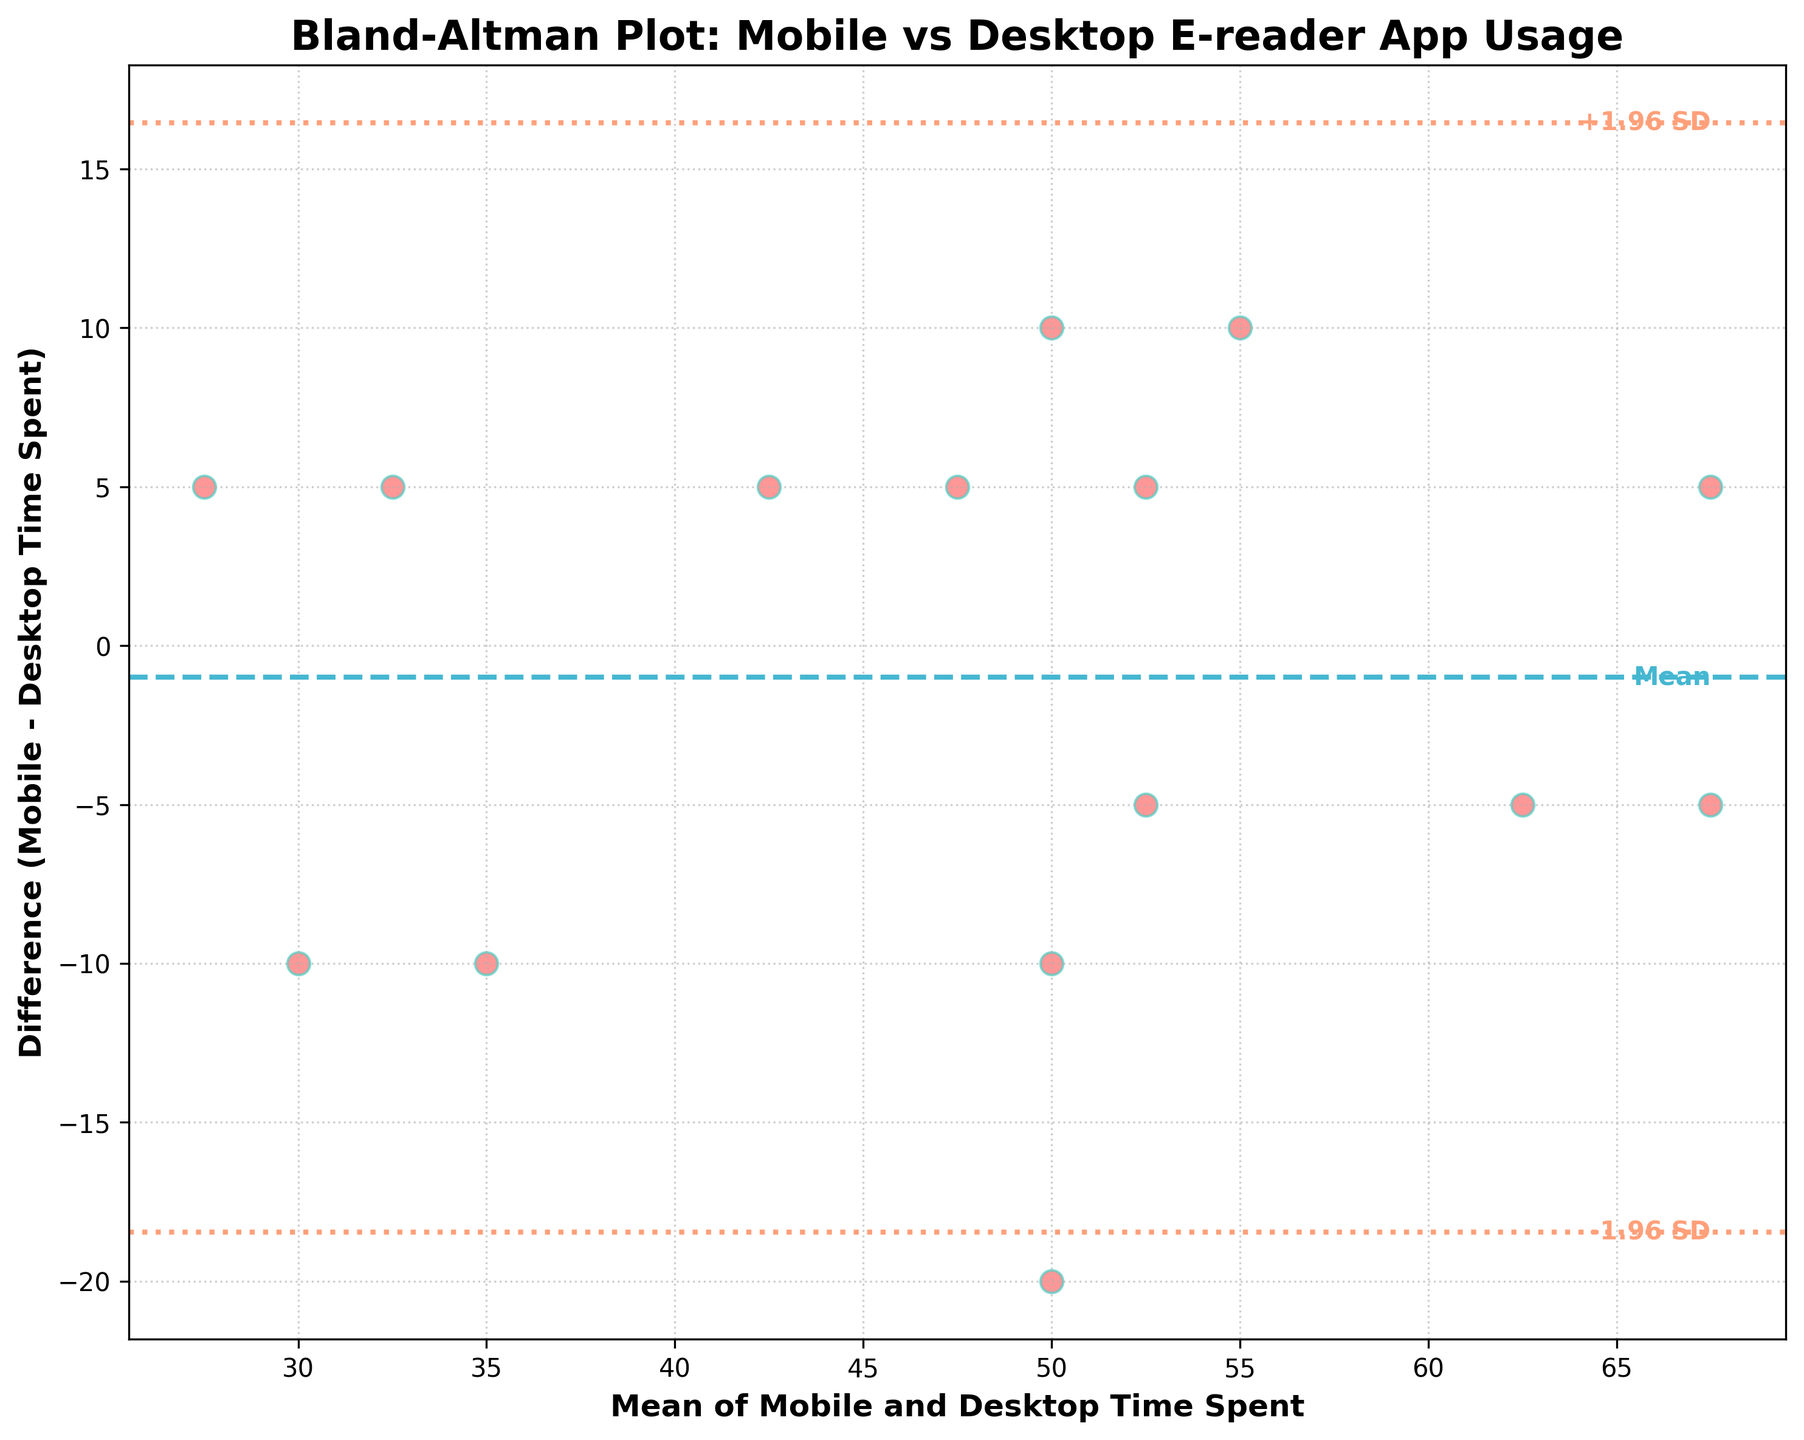What's the title of the plot? The title of the plot is typically located at the top of the figure. In this case, it reads "Bland-Altman Plot: Mobile vs Desktop E-reader App Usage".
Answer: Bland-Altman Plot: Mobile vs Desktop E-reader App Usage How many data points are there in this plot? The number of data points is equal to the number of users whose engagement metrics are plotted. By counting the red scatter points in the figure, we can determine the total.
Answer: 15 What do the horizontal dashed lines in the plot represent? The horizontal dashed lines represent the mean difference and the limits of agreement (LOA). The line in the middle is the mean difference, and the upper and lower lines denote the mean difference ± 1.96 times the standard deviation.
Answer: Mean difference and limits of agreement What is the mean difference between mobile and desktop time spent? The mean difference is indicated by the horizontal dashed line centrally located in the plot. There is also a text label next to this line.
Answer: 0 Based on the limits of agreement, what is the range within which most of the differences lie? The limits of agreement are defined as the mean difference ± 1.96 times the standard deviation. The plot includes labeled horizontal lines for these boundaries.
Answer: -17.36 to 17.36 Are there any points outside the limits of agreement? To find out if any points lie outside the limits of agreement, we visually inspect the scatter plot to see if any red data points fall beyond the upper or lower dashed lines.
Answer: No What can be inferred if the majority of differences are close to zero? If the majority of differences cluster near zero, it suggests that the engagement (time spent) on mobile and desktop versions of the e-reader app is relatively consistent for most users.
Answer: Consistent engagement How does the difference between mobile and desktop time spent change as the mean time spent increases? Observing the scatter plot, we can see if there's a trend in the positioning of red dots (differences) as we move from lower to higher mean values on the x-axis.
Answer: No clear trend What color is used to mark the mean difference line? The dashed line indicating the mean difference in the plot is colored distinctly, which can be identified visually.
Answer: Blue What could a datapoint at a positive difference indicate? A positive difference means that the time spent on the mobile app is greater than the time spent on the desktop app. This can be seen by where the point is on the y-axis relative to zero.
Answer: Mobile > Desktop 